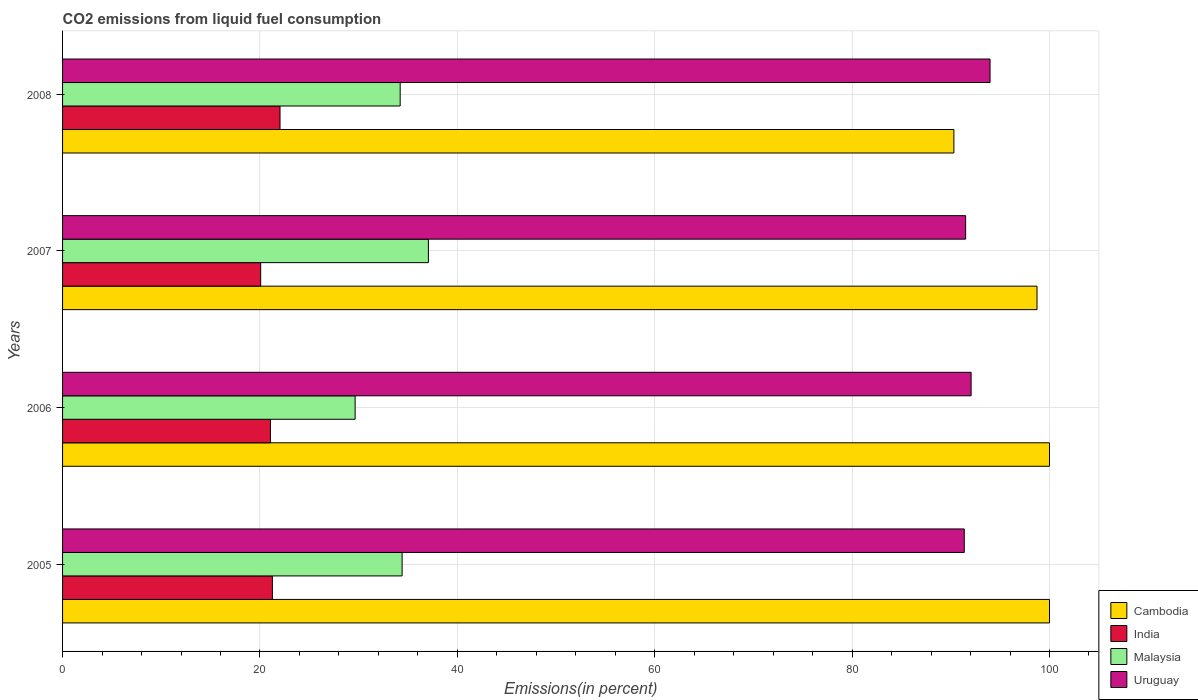Are the number of bars on each tick of the Y-axis equal?
Provide a short and direct response. Yes. How many bars are there on the 1st tick from the top?
Provide a succinct answer. 4. What is the label of the 1st group of bars from the top?
Give a very brief answer. 2008. In how many cases, is the number of bars for a given year not equal to the number of legend labels?
Your response must be concise. 0. What is the total CO2 emitted in Malaysia in 2008?
Offer a very short reply. 34.21. Across all years, what is the maximum total CO2 emitted in India?
Ensure brevity in your answer.  22.03. Across all years, what is the minimum total CO2 emitted in India?
Your response must be concise. 20.08. In which year was the total CO2 emitted in Cambodia maximum?
Make the answer very short. 2005. What is the total total CO2 emitted in Cambodia in the graph?
Provide a short and direct response. 389.05. What is the difference between the total CO2 emitted in Cambodia in 2006 and that in 2008?
Offer a terse response. 9.69. What is the difference between the total CO2 emitted in Uruguay in 2006 and the total CO2 emitted in Cambodia in 2008?
Give a very brief answer. 1.74. What is the average total CO2 emitted in Malaysia per year?
Offer a terse response. 33.83. In the year 2008, what is the difference between the total CO2 emitted in Malaysia and total CO2 emitted in India?
Provide a succinct answer. 12.18. In how many years, is the total CO2 emitted in Uruguay greater than 76 %?
Your answer should be very brief. 4. What is the ratio of the total CO2 emitted in India in 2007 to that in 2008?
Provide a short and direct response. 0.91. Is the difference between the total CO2 emitted in Malaysia in 2007 and 2008 greater than the difference between the total CO2 emitted in India in 2007 and 2008?
Ensure brevity in your answer.  Yes. What is the difference between the highest and the second highest total CO2 emitted in Malaysia?
Keep it short and to the point. 2.66. What is the difference between the highest and the lowest total CO2 emitted in Uruguay?
Give a very brief answer. 2.61. Is the sum of the total CO2 emitted in Uruguay in 2005 and 2007 greater than the maximum total CO2 emitted in Malaysia across all years?
Offer a very short reply. Yes. Is it the case that in every year, the sum of the total CO2 emitted in Malaysia and total CO2 emitted in Cambodia is greater than the sum of total CO2 emitted in Uruguay and total CO2 emitted in India?
Provide a succinct answer. Yes. What does the 2nd bar from the top in 2007 represents?
Your response must be concise. Malaysia. What does the 4th bar from the bottom in 2005 represents?
Your response must be concise. Uruguay. How many bars are there?
Make the answer very short. 16. Are all the bars in the graph horizontal?
Ensure brevity in your answer.  Yes. How many years are there in the graph?
Your answer should be very brief. 4. Does the graph contain grids?
Provide a short and direct response. Yes. How many legend labels are there?
Provide a succinct answer. 4. What is the title of the graph?
Offer a terse response. CO2 emissions from liquid fuel consumption. What is the label or title of the X-axis?
Ensure brevity in your answer.  Emissions(in percent). What is the Emissions(in percent) in Cambodia in 2005?
Your response must be concise. 100. What is the Emissions(in percent) in India in 2005?
Your answer should be compact. 21.26. What is the Emissions(in percent) of Malaysia in 2005?
Your response must be concise. 34.4. What is the Emissions(in percent) of Uruguay in 2005?
Provide a short and direct response. 91.37. What is the Emissions(in percent) of India in 2006?
Your response must be concise. 21.07. What is the Emissions(in percent) of Malaysia in 2006?
Your answer should be very brief. 29.64. What is the Emissions(in percent) of Uruguay in 2006?
Provide a succinct answer. 92.06. What is the Emissions(in percent) of Cambodia in 2007?
Offer a very short reply. 98.74. What is the Emissions(in percent) in India in 2007?
Make the answer very short. 20.08. What is the Emissions(in percent) of Malaysia in 2007?
Offer a terse response. 37.07. What is the Emissions(in percent) of Uruguay in 2007?
Give a very brief answer. 91.5. What is the Emissions(in percent) in Cambodia in 2008?
Offer a terse response. 90.31. What is the Emissions(in percent) in India in 2008?
Offer a terse response. 22.03. What is the Emissions(in percent) in Malaysia in 2008?
Your answer should be compact. 34.21. What is the Emissions(in percent) in Uruguay in 2008?
Keep it short and to the point. 93.98. Across all years, what is the maximum Emissions(in percent) of India?
Provide a short and direct response. 22.03. Across all years, what is the maximum Emissions(in percent) of Malaysia?
Provide a short and direct response. 37.07. Across all years, what is the maximum Emissions(in percent) of Uruguay?
Ensure brevity in your answer.  93.98. Across all years, what is the minimum Emissions(in percent) in Cambodia?
Provide a short and direct response. 90.31. Across all years, what is the minimum Emissions(in percent) of India?
Provide a short and direct response. 20.08. Across all years, what is the minimum Emissions(in percent) in Malaysia?
Keep it short and to the point. 29.64. Across all years, what is the minimum Emissions(in percent) of Uruguay?
Your answer should be compact. 91.37. What is the total Emissions(in percent) of Cambodia in the graph?
Ensure brevity in your answer.  389.05. What is the total Emissions(in percent) in India in the graph?
Make the answer very short. 84.43. What is the total Emissions(in percent) of Malaysia in the graph?
Offer a very short reply. 135.32. What is the total Emissions(in percent) of Uruguay in the graph?
Keep it short and to the point. 368.9. What is the difference between the Emissions(in percent) in Cambodia in 2005 and that in 2006?
Your answer should be very brief. 0. What is the difference between the Emissions(in percent) in India in 2005 and that in 2006?
Make the answer very short. 0.19. What is the difference between the Emissions(in percent) in Malaysia in 2005 and that in 2006?
Give a very brief answer. 4.76. What is the difference between the Emissions(in percent) of Uruguay in 2005 and that in 2006?
Your response must be concise. -0.69. What is the difference between the Emissions(in percent) of Cambodia in 2005 and that in 2007?
Offer a very short reply. 1.26. What is the difference between the Emissions(in percent) in India in 2005 and that in 2007?
Provide a short and direct response. 1.19. What is the difference between the Emissions(in percent) in Malaysia in 2005 and that in 2007?
Keep it short and to the point. -2.66. What is the difference between the Emissions(in percent) in Uruguay in 2005 and that in 2007?
Give a very brief answer. -0.14. What is the difference between the Emissions(in percent) of Cambodia in 2005 and that in 2008?
Provide a short and direct response. 9.69. What is the difference between the Emissions(in percent) in India in 2005 and that in 2008?
Offer a terse response. -0.77. What is the difference between the Emissions(in percent) of Malaysia in 2005 and that in 2008?
Keep it short and to the point. 0.2. What is the difference between the Emissions(in percent) of Uruguay in 2005 and that in 2008?
Provide a short and direct response. -2.61. What is the difference between the Emissions(in percent) in Cambodia in 2006 and that in 2007?
Offer a terse response. 1.26. What is the difference between the Emissions(in percent) of India in 2006 and that in 2007?
Provide a succinct answer. 0.99. What is the difference between the Emissions(in percent) in Malaysia in 2006 and that in 2007?
Offer a terse response. -7.42. What is the difference between the Emissions(in percent) in Uruguay in 2006 and that in 2007?
Your answer should be compact. 0.55. What is the difference between the Emissions(in percent) in Cambodia in 2006 and that in 2008?
Make the answer very short. 9.69. What is the difference between the Emissions(in percent) in India in 2006 and that in 2008?
Make the answer very short. -0.97. What is the difference between the Emissions(in percent) in Malaysia in 2006 and that in 2008?
Your answer should be compact. -4.56. What is the difference between the Emissions(in percent) in Uruguay in 2006 and that in 2008?
Keep it short and to the point. -1.92. What is the difference between the Emissions(in percent) of Cambodia in 2007 and that in 2008?
Provide a succinct answer. 8.42. What is the difference between the Emissions(in percent) in India in 2007 and that in 2008?
Make the answer very short. -1.96. What is the difference between the Emissions(in percent) in Malaysia in 2007 and that in 2008?
Make the answer very short. 2.86. What is the difference between the Emissions(in percent) in Uruguay in 2007 and that in 2008?
Offer a very short reply. -2.47. What is the difference between the Emissions(in percent) in Cambodia in 2005 and the Emissions(in percent) in India in 2006?
Ensure brevity in your answer.  78.93. What is the difference between the Emissions(in percent) of Cambodia in 2005 and the Emissions(in percent) of Malaysia in 2006?
Keep it short and to the point. 70.36. What is the difference between the Emissions(in percent) in Cambodia in 2005 and the Emissions(in percent) in Uruguay in 2006?
Offer a very short reply. 7.94. What is the difference between the Emissions(in percent) in India in 2005 and the Emissions(in percent) in Malaysia in 2006?
Your answer should be very brief. -8.38. What is the difference between the Emissions(in percent) of India in 2005 and the Emissions(in percent) of Uruguay in 2006?
Make the answer very short. -70.8. What is the difference between the Emissions(in percent) in Malaysia in 2005 and the Emissions(in percent) in Uruguay in 2006?
Give a very brief answer. -57.65. What is the difference between the Emissions(in percent) in Cambodia in 2005 and the Emissions(in percent) in India in 2007?
Your answer should be compact. 79.92. What is the difference between the Emissions(in percent) in Cambodia in 2005 and the Emissions(in percent) in Malaysia in 2007?
Make the answer very short. 62.93. What is the difference between the Emissions(in percent) of Cambodia in 2005 and the Emissions(in percent) of Uruguay in 2007?
Make the answer very short. 8.5. What is the difference between the Emissions(in percent) of India in 2005 and the Emissions(in percent) of Malaysia in 2007?
Your answer should be very brief. -15.81. What is the difference between the Emissions(in percent) in India in 2005 and the Emissions(in percent) in Uruguay in 2007?
Offer a very short reply. -70.24. What is the difference between the Emissions(in percent) in Malaysia in 2005 and the Emissions(in percent) in Uruguay in 2007?
Provide a succinct answer. -57.1. What is the difference between the Emissions(in percent) of Cambodia in 2005 and the Emissions(in percent) of India in 2008?
Ensure brevity in your answer.  77.97. What is the difference between the Emissions(in percent) in Cambodia in 2005 and the Emissions(in percent) in Malaysia in 2008?
Your answer should be very brief. 65.79. What is the difference between the Emissions(in percent) in Cambodia in 2005 and the Emissions(in percent) in Uruguay in 2008?
Offer a terse response. 6.02. What is the difference between the Emissions(in percent) of India in 2005 and the Emissions(in percent) of Malaysia in 2008?
Offer a terse response. -12.95. What is the difference between the Emissions(in percent) of India in 2005 and the Emissions(in percent) of Uruguay in 2008?
Your answer should be very brief. -72.72. What is the difference between the Emissions(in percent) of Malaysia in 2005 and the Emissions(in percent) of Uruguay in 2008?
Keep it short and to the point. -59.57. What is the difference between the Emissions(in percent) of Cambodia in 2006 and the Emissions(in percent) of India in 2007?
Offer a terse response. 79.92. What is the difference between the Emissions(in percent) of Cambodia in 2006 and the Emissions(in percent) of Malaysia in 2007?
Make the answer very short. 62.93. What is the difference between the Emissions(in percent) of Cambodia in 2006 and the Emissions(in percent) of Uruguay in 2007?
Offer a very short reply. 8.5. What is the difference between the Emissions(in percent) in India in 2006 and the Emissions(in percent) in Malaysia in 2007?
Provide a succinct answer. -16. What is the difference between the Emissions(in percent) of India in 2006 and the Emissions(in percent) of Uruguay in 2007?
Offer a very short reply. -70.44. What is the difference between the Emissions(in percent) of Malaysia in 2006 and the Emissions(in percent) of Uruguay in 2007?
Provide a short and direct response. -61.86. What is the difference between the Emissions(in percent) of Cambodia in 2006 and the Emissions(in percent) of India in 2008?
Offer a terse response. 77.97. What is the difference between the Emissions(in percent) of Cambodia in 2006 and the Emissions(in percent) of Malaysia in 2008?
Your answer should be compact. 65.79. What is the difference between the Emissions(in percent) in Cambodia in 2006 and the Emissions(in percent) in Uruguay in 2008?
Your response must be concise. 6.02. What is the difference between the Emissions(in percent) of India in 2006 and the Emissions(in percent) of Malaysia in 2008?
Make the answer very short. -13.14. What is the difference between the Emissions(in percent) of India in 2006 and the Emissions(in percent) of Uruguay in 2008?
Provide a succinct answer. -72.91. What is the difference between the Emissions(in percent) in Malaysia in 2006 and the Emissions(in percent) in Uruguay in 2008?
Ensure brevity in your answer.  -64.33. What is the difference between the Emissions(in percent) in Cambodia in 2007 and the Emissions(in percent) in India in 2008?
Your response must be concise. 76.7. What is the difference between the Emissions(in percent) of Cambodia in 2007 and the Emissions(in percent) of Malaysia in 2008?
Provide a short and direct response. 64.53. What is the difference between the Emissions(in percent) of Cambodia in 2007 and the Emissions(in percent) of Uruguay in 2008?
Ensure brevity in your answer.  4.76. What is the difference between the Emissions(in percent) in India in 2007 and the Emissions(in percent) in Malaysia in 2008?
Provide a short and direct response. -14.13. What is the difference between the Emissions(in percent) of India in 2007 and the Emissions(in percent) of Uruguay in 2008?
Your answer should be compact. -73.9. What is the difference between the Emissions(in percent) in Malaysia in 2007 and the Emissions(in percent) in Uruguay in 2008?
Provide a short and direct response. -56.91. What is the average Emissions(in percent) of Cambodia per year?
Ensure brevity in your answer.  97.26. What is the average Emissions(in percent) in India per year?
Ensure brevity in your answer.  21.11. What is the average Emissions(in percent) in Malaysia per year?
Your response must be concise. 33.83. What is the average Emissions(in percent) in Uruguay per year?
Your answer should be compact. 92.23. In the year 2005, what is the difference between the Emissions(in percent) of Cambodia and Emissions(in percent) of India?
Your response must be concise. 78.74. In the year 2005, what is the difference between the Emissions(in percent) of Cambodia and Emissions(in percent) of Malaysia?
Make the answer very short. 65.6. In the year 2005, what is the difference between the Emissions(in percent) in Cambodia and Emissions(in percent) in Uruguay?
Your response must be concise. 8.63. In the year 2005, what is the difference between the Emissions(in percent) in India and Emissions(in percent) in Malaysia?
Provide a succinct answer. -13.14. In the year 2005, what is the difference between the Emissions(in percent) in India and Emissions(in percent) in Uruguay?
Provide a short and direct response. -70.1. In the year 2005, what is the difference between the Emissions(in percent) of Malaysia and Emissions(in percent) of Uruguay?
Ensure brevity in your answer.  -56.96. In the year 2006, what is the difference between the Emissions(in percent) in Cambodia and Emissions(in percent) in India?
Ensure brevity in your answer.  78.93. In the year 2006, what is the difference between the Emissions(in percent) in Cambodia and Emissions(in percent) in Malaysia?
Provide a succinct answer. 70.36. In the year 2006, what is the difference between the Emissions(in percent) of Cambodia and Emissions(in percent) of Uruguay?
Provide a short and direct response. 7.94. In the year 2006, what is the difference between the Emissions(in percent) of India and Emissions(in percent) of Malaysia?
Your answer should be compact. -8.58. In the year 2006, what is the difference between the Emissions(in percent) in India and Emissions(in percent) in Uruguay?
Your answer should be compact. -70.99. In the year 2006, what is the difference between the Emissions(in percent) in Malaysia and Emissions(in percent) in Uruguay?
Give a very brief answer. -62.41. In the year 2007, what is the difference between the Emissions(in percent) of Cambodia and Emissions(in percent) of India?
Offer a terse response. 78.66. In the year 2007, what is the difference between the Emissions(in percent) of Cambodia and Emissions(in percent) of Malaysia?
Your answer should be very brief. 61.67. In the year 2007, what is the difference between the Emissions(in percent) in Cambodia and Emissions(in percent) in Uruguay?
Your answer should be very brief. 7.23. In the year 2007, what is the difference between the Emissions(in percent) in India and Emissions(in percent) in Malaysia?
Your response must be concise. -16.99. In the year 2007, what is the difference between the Emissions(in percent) in India and Emissions(in percent) in Uruguay?
Offer a very short reply. -71.43. In the year 2007, what is the difference between the Emissions(in percent) of Malaysia and Emissions(in percent) of Uruguay?
Give a very brief answer. -54.44. In the year 2008, what is the difference between the Emissions(in percent) in Cambodia and Emissions(in percent) in India?
Make the answer very short. 68.28. In the year 2008, what is the difference between the Emissions(in percent) in Cambodia and Emissions(in percent) in Malaysia?
Ensure brevity in your answer.  56.11. In the year 2008, what is the difference between the Emissions(in percent) of Cambodia and Emissions(in percent) of Uruguay?
Give a very brief answer. -3.66. In the year 2008, what is the difference between the Emissions(in percent) of India and Emissions(in percent) of Malaysia?
Give a very brief answer. -12.18. In the year 2008, what is the difference between the Emissions(in percent) of India and Emissions(in percent) of Uruguay?
Make the answer very short. -71.94. In the year 2008, what is the difference between the Emissions(in percent) in Malaysia and Emissions(in percent) in Uruguay?
Offer a very short reply. -59.77. What is the ratio of the Emissions(in percent) in Cambodia in 2005 to that in 2006?
Give a very brief answer. 1. What is the ratio of the Emissions(in percent) in India in 2005 to that in 2006?
Keep it short and to the point. 1.01. What is the ratio of the Emissions(in percent) of Malaysia in 2005 to that in 2006?
Ensure brevity in your answer.  1.16. What is the ratio of the Emissions(in percent) in Cambodia in 2005 to that in 2007?
Offer a terse response. 1.01. What is the ratio of the Emissions(in percent) of India in 2005 to that in 2007?
Provide a short and direct response. 1.06. What is the ratio of the Emissions(in percent) of Malaysia in 2005 to that in 2007?
Give a very brief answer. 0.93. What is the ratio of the Emissions(in percent) of Cambodia in 2005 to that in 2008?
Offer a terse response. 1.11. What is the ratio of the Emissions(in percent) in India in 2005 to that in 2008?
Make the answer very short. 0.96. What is the ratio of the Emissions(in percent) in Malaysia in 2005 to that in 2008?
Offer a very short reply. 1.01. What is the ratio of the Emissions(in percent) in Uruguay in 2005 to that in 2008?
Provide a succinct answer. 0.97. What is the ratio of the Emissions(in percent) in Cambodia in 2006 to that in 2007?
Give a very brief answer. 1.01. What is the ratio of the Emissions(in percent) of India in 2006 to that in 2007?
Provide a short and direct response. 1.05. What is the ratio of the Emissions(in percent) of Malaysia in 2006 to that in 2007?
Your response must be concise. 0.8. What is the ratio of the Emissions(in percent) of Uruguay in 2006 to that in 2007?
Your answer should be compact. 1.01. What is the ratio of the Emissions(in percent) in Cambodia in 2006 to that in 2008?
Your answer should be very brief. 1.11. What is the ratio of the Emissions(in percent) in India in 2006 to that in 2008?
Your answer should be very brief. 0.96. What is the ratio of the Emissions(in percent) in Malaysia in 2006 to that in 2008?
Offer a terse response. 0.87. What is the ratio of the Emissions(in percent) in Uruguay in 2006 to that in 2008?
Offer a very short reply. 0.98. What is the ratio of the Emissions(in percent) in Cambodia in 2007 to that in 2008?
Make the answer very short. 1.09. What is the ratio of the Emissions(in percent) of India in 2007 to that in 2008?
Provide a short and direct response. 0.91. What is the ratio of the Emissions(in percent) in Malaysia in 2007 to that in 2008?
Keep it short and to the point. 1.08. What is the ratio of the Emissions(in percent) in Uruguay in 2007 to that in 2008?
Give a very brief answer. 0.97. What is the difference between the highest and the second highest Emissions(in percent) of India?
Offer a very short reply. 0.77. What is the difference between the highest and the second highest Emissions(in percent) in Malaysia?
Offer a terse response. 2.66. What is the difference between the highest and the second highest Emissions(in percent) in Uruguay?
Provide a short and direct response. 1.92. What is the difference between the highest and the lowest Emissions(in percent) of Cambodia?
Your answer should be compact. 9.69. What is the difference between the highest and the lowest Emissions(in percent) of India?
Ensure brevity in your answer.  1.96. What is the difference between the highest and the lowest Emissions(in percent) in Malaysia?
Offer a terse response. 7.42. What is the difference between the highest and the lowest Emissions(in percent) of Uruguay?
Your answer should be compact. 2.61. 